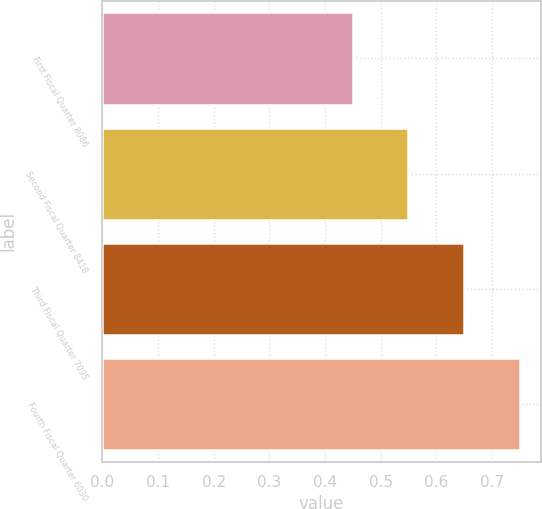<chart> <loc_0><loc_0><loc_500><loc_500><bar_chart><fcel>First Fiscal Quarter 8086<fcel>Second Fiscal Quarter 8418<fcel>Third Fiscal Quarter 7095<fcel>Fourth Fiscal Quarter 6030<nl><fcel>0.45<fcel>0.55<fcel>0.65<fcel>0.75<nl></chart> 